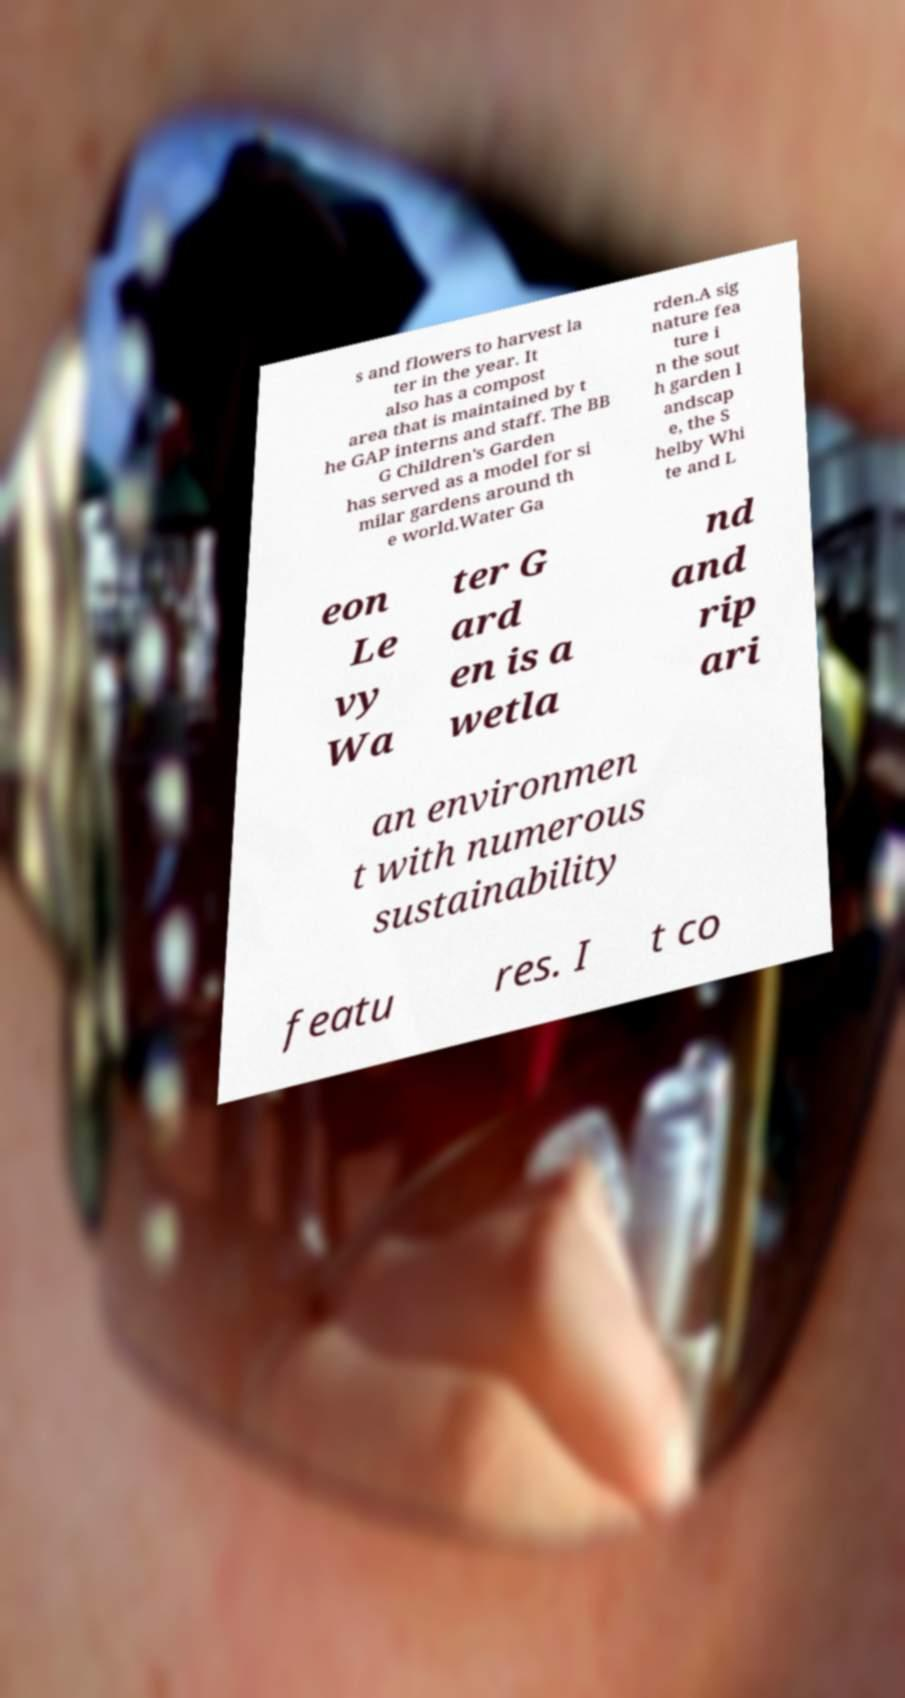For documentation purposes, I need the text within this image transcribed. Could you provide that? s and flowers to harvest la ter in the year. It also has a compost area that is maintained by t he GAP interns and staff. The BB G Children's Garden has served as a model for si milar gardens around th e world.Water Ga rden.A sig nature fea ture i n the sout h garden l andscap e, the S helby Whi te and L eon Le vy Wa ter G ard en is a wetla nd and rip ari an environmen t with numerous sustainability featu res. I t co 